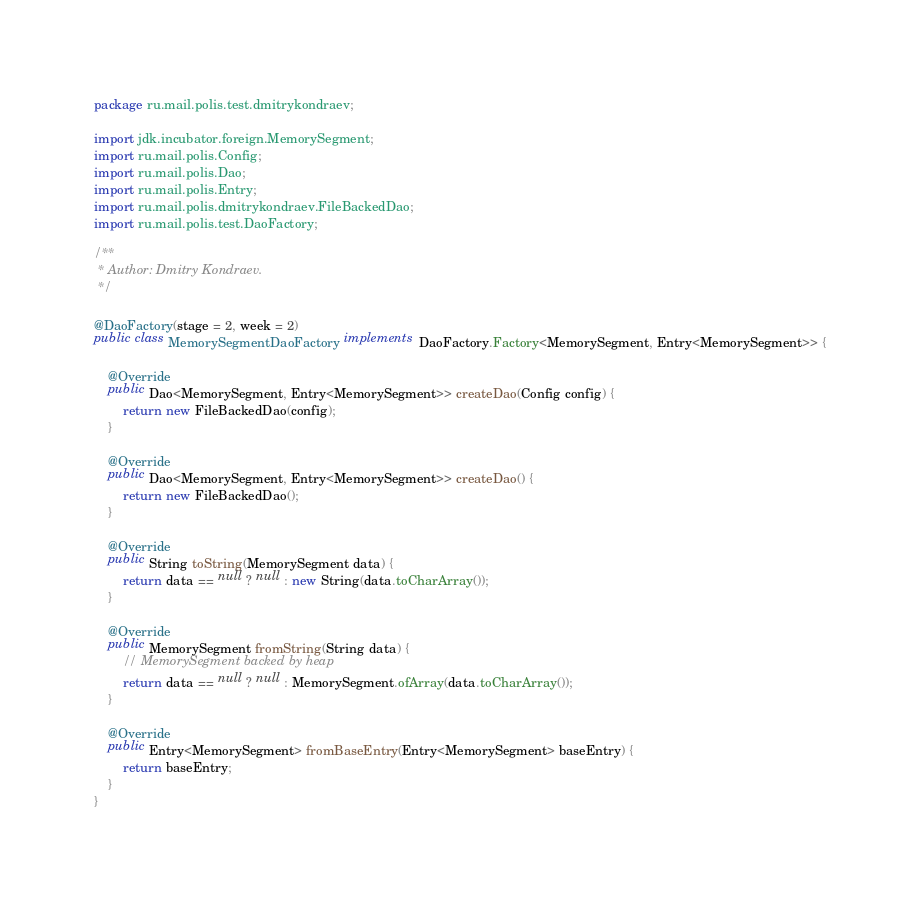<code> <loc_0><loc_0><loc_500><loc_500><_Java_>package ru.mail.polis.test.dmitrykondraev;

import jdk.incubator.foreign.MemorySegment;
import ru.mail.polis.Config;
import ru.mail.polis.Dao;
import ru.mail.polis.Entry;
import ru.mail.polis.dmitrykondraev.FileBackedDao;
import ru.mail.polis.test.DaoFactory;

/**
 * Author: Dmitry Kondraev.
 */

@DaoFactory(stage = 2, week = 2)
public class MemorySegmentDaoFactory implements DaoFactory.Factory<MemorySegment, Entry<MemorySegment>> {

    @Override
    public Dao<MemorySegment, Entry<MemorySegment>> createDao(Config config) {
        return new FileBackedDao(config);
    }

    @Override
    public Dao<MemorySegment, Entry<MemorySegment>> createDao() {
        return new FileBackedDao();
    }

    @Override
    public String toString(MemorySegment data) {
        return data == null ? null : new String(data.toCharArray());
    }

    @Override
    public MemorySegment fromString(String data) {
        // MemorySegment backed by heap
        return data == null ? null : MemorySegment.ofArray(data.toCharArray());
    }

    @Override
    public Entry<MemorySegment> fromBaseEntry(Entry<MemorySegment> baseEntry) {
        return baseEntry;
    }
}
</code> 